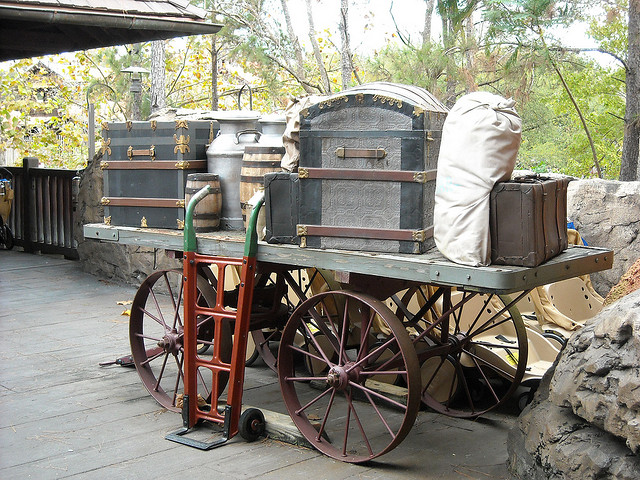How many cows are photographed? 0 